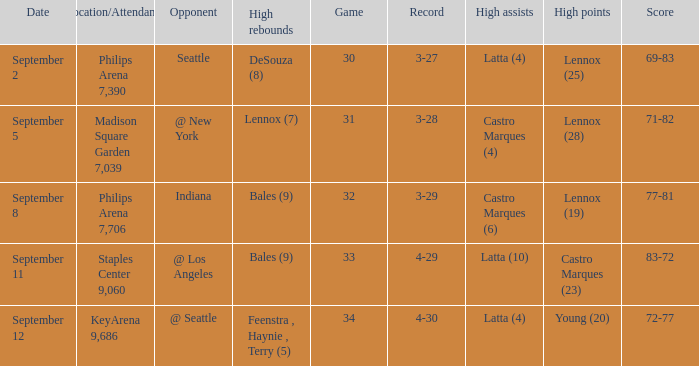What was the Location/Attendance on september 11? Staples Center 9,060. Parse the full table. {'header': ['Date', 'Location/Attendance', 'Opponent', 'High rebounds', 'Game', 'Record', 'High assists', 'High points', 'Score'], 'rows': [['September 2', 'Philips Arena 7,390', 'Seattle', 'DeSouza (8)', '30', '3-27', 'Latta (4)', 'Lennox (25)', '69-83'], ['September 5', 'Madison Square Garden 7,039', '@ New York', 'Lennox (7)', '31', '3-28', 'Castro Marques (4)', 'Lennox (28)', '71-82'], ['September 8', 'Philips Arena 7,706', 'Indiana', 'Bales (9)', '32', '3-29', 'Castro Marques (6)', 'Lennox (19)', '77-81'], ['September 11', 'Staples Center 9,060', '@ Los Angeles', 'Bales (9)', '33', '4-29', 'Latta (10)', 'Castro Marques (23)', '83-72'], ['September 12', 'KeyArena 9,686', '@ Seattle', 'Feenstra , Haynie , Terry (5)', '34', '4-30', 'Latta (4)', 'Young (20)', '72-77']]} 